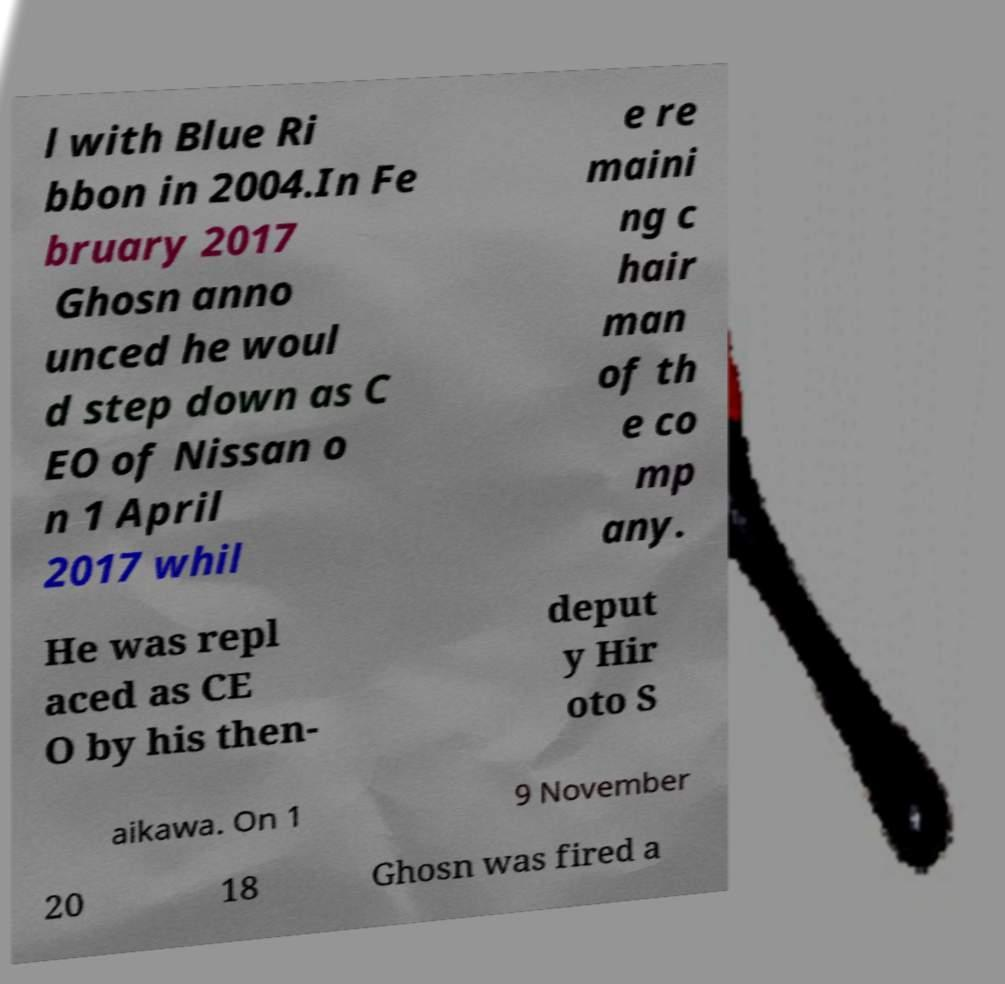Please identify and transcribe the text found in this image. l with Blue Ri bbon in 2004.In Fe bruary 2017 Ghosn anno unced he woul d step down as C EO of Nissan o n 1 April 2017 whil e re maini ng c hair man of th e co mp any. He was repl aced as CE O by his then- deput y Hir oto S aikawa. On 1 9 November 20 18 Ghosn was fired a 